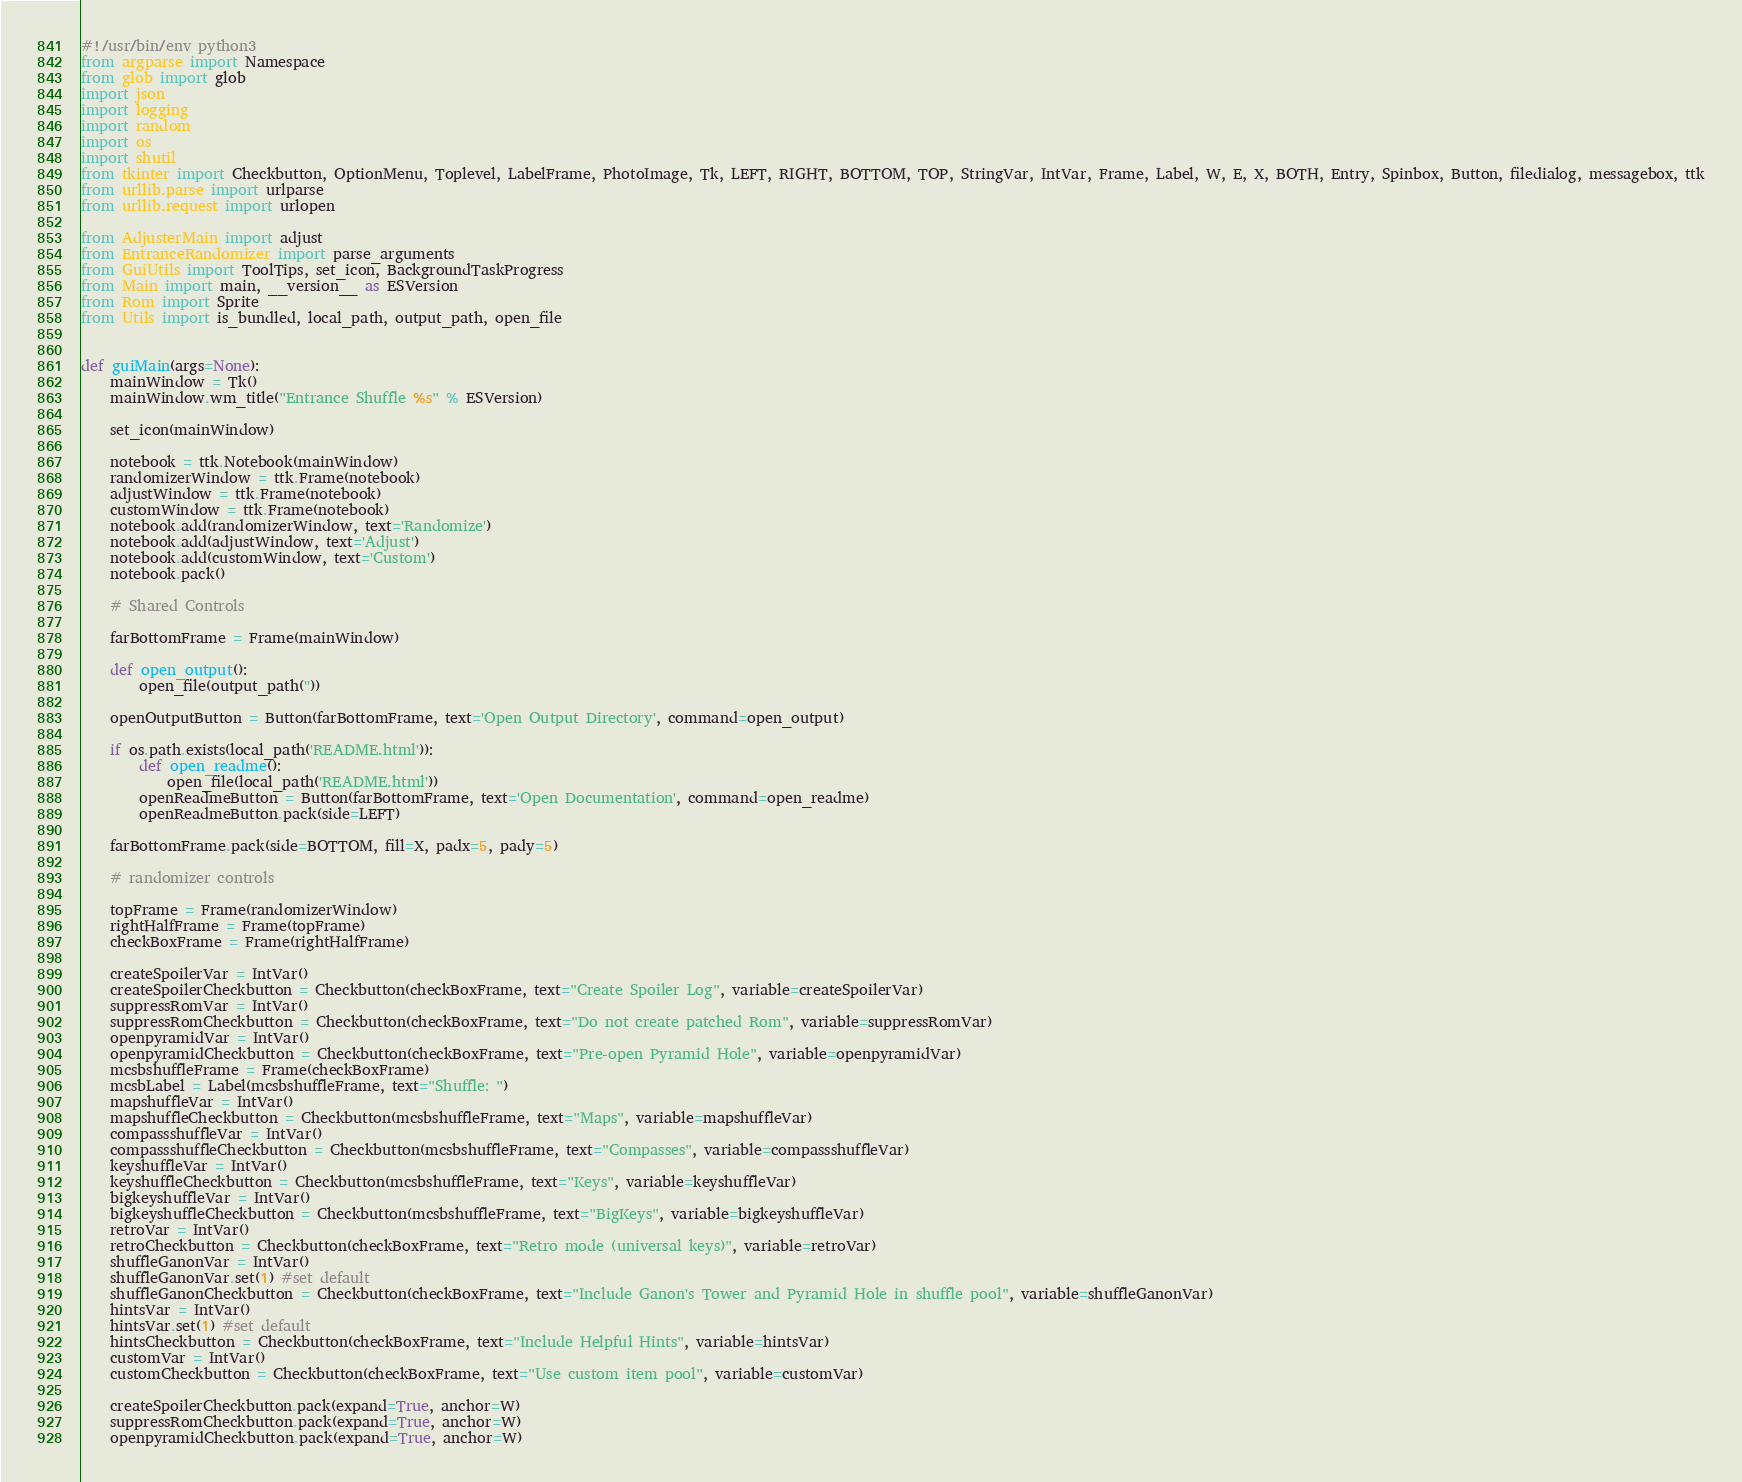Convert code to text. <code><loc_0><loc_0><loc_500><loc_500><_Python_>#!/usr/bin/env python3
from argparse import Namespace
from glob import glob
import json
import logging
import random
import os
import shutil
from tkinter import Checkbutton, OptionMenu, Toplevel, LabelFrame, PhotoImage, Tk, LEFT, RIGHT, BOTTOM, TOP, StringVar, IntVar, Frame, Label, W, E, X, BOTH, Entry, Spinbox, Button, filedialog, messagebox, ttk
from urllib.parse import urlparse
from urllib.request import urlopen

from AdjusterMain import adjust
from EntranceRandomizer import parse_arguments
from GuiUtils import ToolTips, set_icon, BackgroundTaskProgress
from Main import main, __version__ as ESVersion
from Rom import Sprite
from Utils import is_bundled, local_path, output_path, open_file


def guiMain(args=None):
    mainWindow = Tk()
    mainWindow.wm_title("Entrance Shuffle %s" % ESVersion)

    set_icon(mainWindow)

    notebook = ttk.Notebook(mainWindow)
    randomizerWindow = ttk.Frame(notebook)
    adjustWindow = ttk.Frame(notebook)
    customWindow = ttk.Frame(notebook)
    notebook.add(randomizerWindow, text='Randomize')
    notebook.add(adjustWindow, text='Adjust')
    notebook.add(customWindow, text='Custom')
    notebook.pack()

    # Shared Controls

    farBottomFrame = Frame(mainWindow)

    def open_output():
        open_file(output_path(''))

    openOutputButton = Button(farBottomFrame, text='Open Output Directory', command=open_output)

    if os.path.exists(local_path('README.html')):
        def open_readme():
            open_file(local_path('README.html'))
        openReadmeButton = Button(farBottomFrame, text='Open Documentation', command=open_readme)
        openReadmeButton.pack(side=LEFT)

    farBottomFrame.pack(side=BOTTOM, fill=X, padx=5, pady=5)

    # randomizer controls

    topFrame = Frame(randomizerWindow)
    rightHalfFrame = Frame(topFrame)
    checkBoxFrame = Frame(rightHalfFrame)

    createSpoilerVar = IntVar()
    createSpoilerCheckbutton = Checkbutton(checkBoxFrame, text="Create Spoiler Log", variable=createSpoilerVar)
    suppressRomVar = IntVar()
    suppressRomCheckbutton = Checkbutton(checkBoxFrame, text="Do not create patched Rom", variable=suppressRomVar)
    openpyramidVar = IntVar()
    openpyramidCheckbutton = Checkbutton(checkBoxFrame, text="Pre-open Pyramid Hole", variable=openpyramidVar)
    mcsbshuffleFrame = Frame(checkBoxFrame)
    mcsbLabel = Label(mcsbshuffleFrame, text="Shuffle: ")
    mapshuffleVar = IntVar()
    mapshuffleCheckbutton = Checkbutton(mcsbshuffleFrame, text="Maps", variable=mapshuffleVar)
    compassshuffleVar = IntVar()
    compassshuffleCheckbutton = Checkbutton(mcsbshuffleFrame, text="Compasses", variable=compassshuffleVar)
    keyshuffleVar = IntVar()
    keyshuffleCheckbutton = Checkbutton(mcsbshuffleFrame, text="Keys", variable=keyshuffleVar)
    bigkeyshuffleVar = IntVar()
    bigkeyshuffleCheckbutton = Checkbutton(mcsbshuffleFrame, text="BigKeys", variable=bigkeyshuffleVar)
    retroVar = IntVar()
    retroCheckbutton = Checkbutton(checkBoxFrame, text="Retro mode (universal keys)", variable=retroVar)
    shuffleGanonVar = IntVar()
    shuffleGanonVar.set(1) #set default
    shuffleGanonCheckbutton = Checkbutton(checkBoxFrame, text="Include Ganon's Tower and Pyramid Hole in shuffle pool", variable=shuffleGanonVar)
    hintsVar = IntVar()
    hintsVar.set(1) #set default
    hintsCheckbutton = Checkbutton(checkBoxFrame, text="Include Helpful Hints", variable=hintsVar)
    customVar = IntVar()
    customCheckbutton = Checkbutton(checkBoxFrame, text="Use custom item pool", variable=customVar)

    createSpoilerCheckbutton.pack(expand=True, anchor=W)
    suppressRomCheckbutton.pack(expand=True, anchor=W)
    openpyramidCheckbutton.pack(expand=True, anchor=W)</code> 